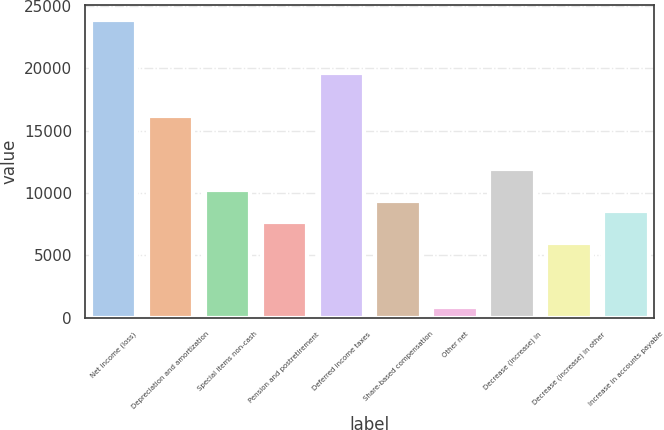<chart> <loc_0><loc_0><loc_500><loc_500><bar_chart><fcel>Net income (loss)<fcel>Depreciation and amortization<fcel>Special items non-cash<fcel>Pension and postretirement<fcel>Deferred income taxes<fcel>Share-based compensation<fcel>Other net<fcel>Decrease (increase) in<fcel>Decrease (increase) in other<fcel>Increase in accounts payable<nl><fcel>23836.8<fcel>16176.9<fcel>10219.2<fcel>7665.9<fcel>19581.3<fcel>9368.1<fcel>857.1<fcel>11921.4<fcel>5963.7<fcel>8517<nl></chart> 